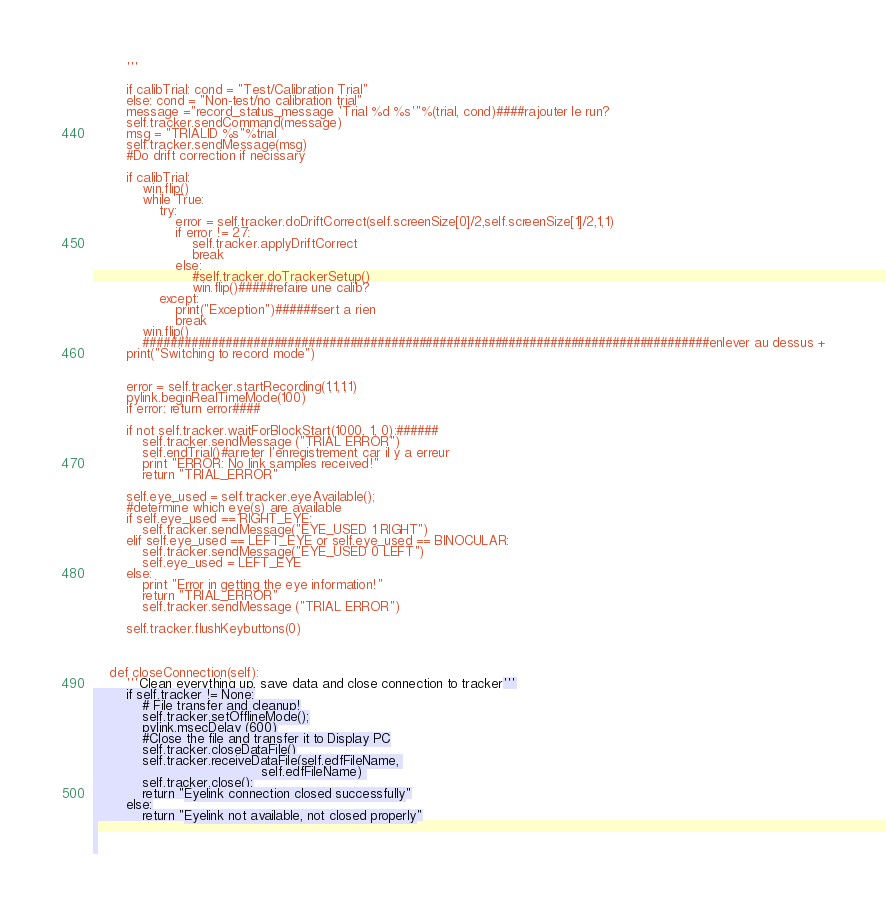Convert code to text. <code><loc_0><loc_0><loc_500><loc_500><_Python_>		'''
 
		if calibTrial: cond = "Test/Calibration Trial"
		else: cond = "Non-test/no calibration trial"
		message ="record_status_message 'Trial %d %s'"%(trial, cond)####rajouter le run?
		self.tracker.sendCommand(message)
		msg = "TRIALID %s"%trial
		self.tracker.sendMessage(msg)
		#Do drift correction if necissary
 
		if calibTrial:
			win.flip()
			while True:
				try:
					error = self.tracker.doDriftCorrect(self.screenSize[0]/2,self.screenSize[1]/2,1,1) 
					if error != 27:
						self.tracker.applyDriftCorrect
						break
					else:
						#self.tracker.doTrackerSetup()
						win.flip()#####refaire une calib?
				except:
					print("Exception")######sert a rien
					break
			win.flip()
			##################################################################################enlever au dessus +
		print("Switching to record mode")


		error = self.tracker.startRecording(1,1,1,1)
		pylink.beginRealTimeMode(100)
		if error: return error####
 
		if not self.tracker.waitForBlockStart(1000, 1, 0):######
			self.tracker.sendMessage ("TRIAL ERROR")
			self.endTrial()#arreter l'enregistrement car il y a erreur
			print "ERROR: No link samples received!"
			return "TRIAL_ERROR"
			
		self.eye_used = self.tracker.eyeAvailable(); 
		#determine which eye(s) are available
		if self.eye_used == RIGHT_EYE:
			self.tracker.sendMessage("EYE_USED 1 RIGHT")
		elif self.eye_used == LEFT_EYE or self.eye_used == BINOCULAR:
			self.tracker.sendMessage("EYE_USED 0 LEFT")
			self.eye_used = LEFT_EYE
		else:
			print "Error in getting the eye information!"
			return "TRIAL_ERROR"
			self.tracker.sendMessage ("TRIAL ERROR")
 
		self.tracker.flushKeybuttons(0)
 
 
 
	def closeConnection(self):
		'''Clean everything up, save data and close connection to tracker'''
		if self.tracker != None:
			# File transfer and cleanup!
			self.tracker.setOfflineMode();
			pylink.msecDelay (600)
			#Close the file and transfer it to Display PC
			self.tracker.closeDataFile()
			self.tracker.receiveDataFile(self.edfFileName, 
										 self.edfFileName) 
			self.tracker.close();
			return "Eyelink connection closed successfully"
		else:
			return "Eyelink not available, not closed properly"
 
 
 </code> 